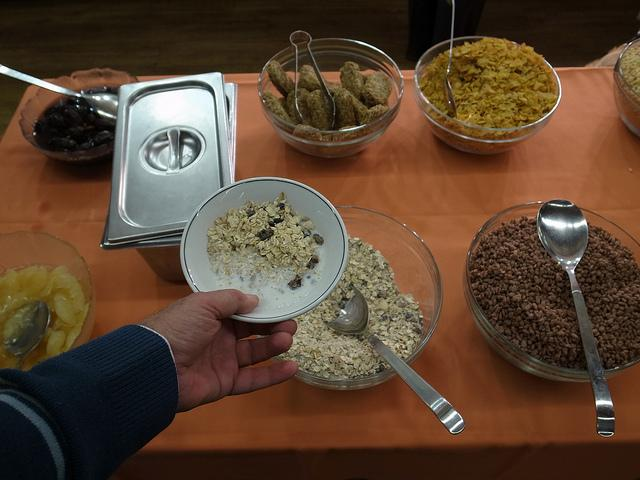What's most likely in the box? Please explain your reasoning. more food. The box has food. 